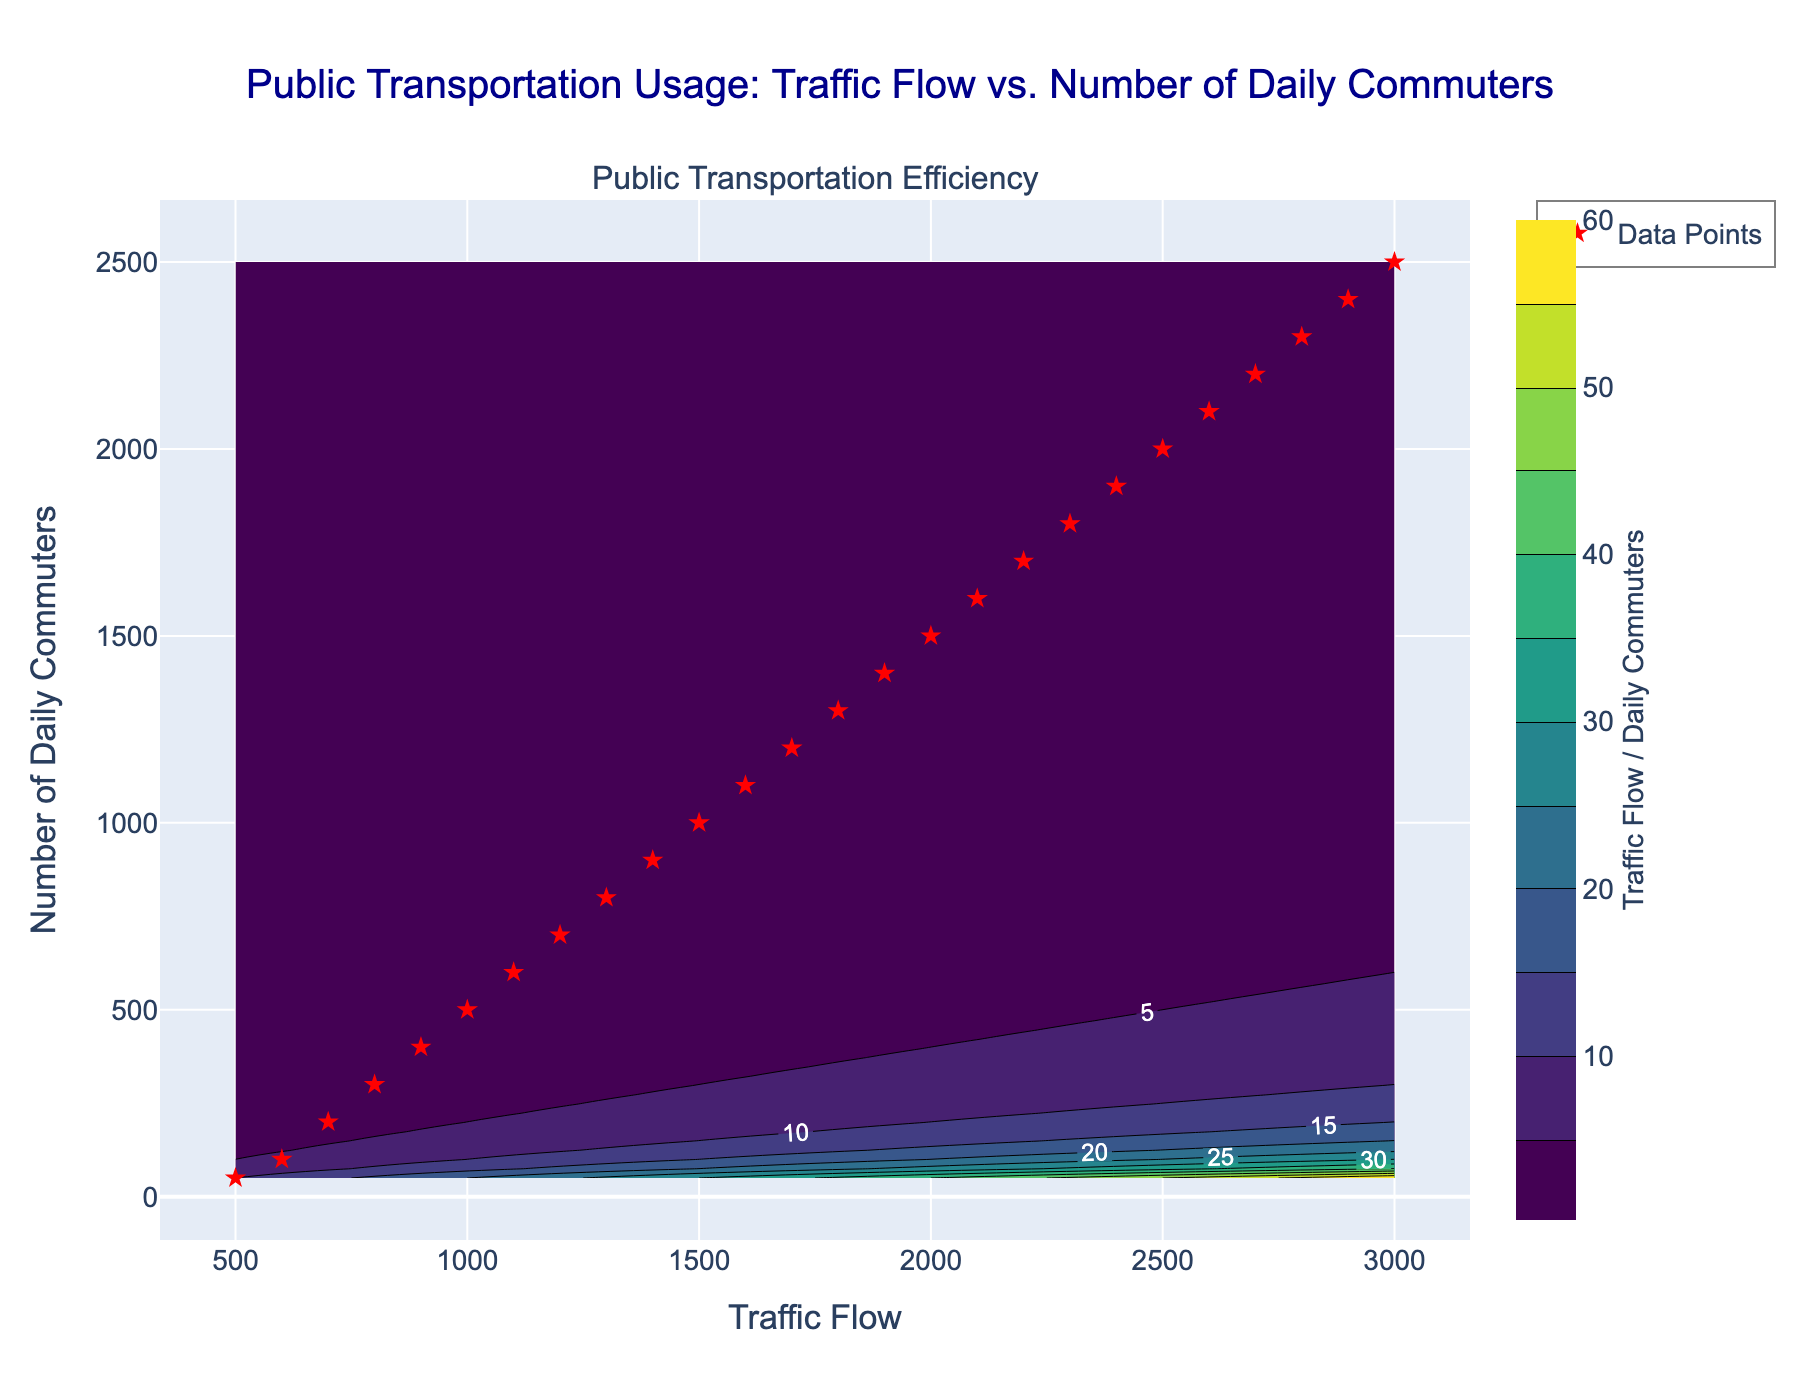How many major data points are marked on the plot? The plot shows 'Data Points' marked with red star symbols, and they represent the major data points. By counting these red stars, we can determine the number of major data points. There are 26 red stars visible on the plot.
Answer: 26 What is the title of the contour plot? The title is clearly displayed at the top of the plot. It reads "Public Transportation Usage: Traffic Flow vs. Number of Daily Commuters".
Answer: Public Transportation Usage: Traffic Flow vs. Number of Daily Commuters Which axis represents the 'Traffic Flow'? The x-axis, which is indicated at the bottom of the plot, represents the 'Traffic Flow'. It's labeled as "Traffic Flow".
Answer: x-axis What is the highest value of 'Traffic Flow' marked on the plot? The highest value on the x-axis where the data points are present is 3000, as indicated by the rightmost data point.
Answer: 3000 What happens to the efficiency as the 'Traffic Flow' increases while keeping 'Number of Daily Commuters' constant? The efficiency, represented by the contour values, decreases as 'Traffic Flow' increases while keeping 'Number of Daily Commuters' constant. This can be observed by moving horizontally across the plot, where the contour values get smaller.
Answer: decreases Which data point has the lowest traffic flow and how many daily commuters does it have? To find the lowest traffic flow, we look at the leftmost red star symbol which marks the data points. The leftmost point is at 500 Traffic Flow. The y-value of this point, which represents the number of daily commuters, is 50.
Answer: 500 Traffic Flow, 50 Daily Commuters What is the relationship between 'Traffic Flow' and 'Efficiency' for a fixed number of daily commuters? By examining the contour lines horizontally on the plot for a fixed y-value, it can be observed that as the 'Traffic Flow' increases, the efficiency (Traffic Flow / Daily Commuters) decreases because the value along the contours drops.
Answer: Inverse relationship If a city has 2000 daily commuters, what range of traffic flow values are they dealing with in terms of efficiency on the plot? The y-axis value of 2000 daily commuters intersects several contour lines. By looking at the plot, the x-axis values corresponding to y=2000 range approximately from 2500 to 2750. This range represents the span of traffic flow values at that level of efficiency.
Answer: 2500 to 2750 What color on the contours indicates the highest efficiency and where is it located on the plot? The Viridis color scale is used, where the color that indicates the highest efficiency is bright yellow-green. These areas of highest efficiency are located in the lower left corner of the plot where the 'Traffic Flow' and 'Number of Daily Commuters' values are low.
Answer: Bright yellow-green, lower left corner What is the trend in the contour lines as we move diagonally from the lower left to the upper right of the plot? Observing the plot, moving diagonally from the lower left to the upper right shows contour lines becoming denser and the values decreasing, indicating that the efficiency is reducing as both 'Traffic Flow' and 'Number of Daily Commuters' increase.
Answer: Decreasing efficiency 